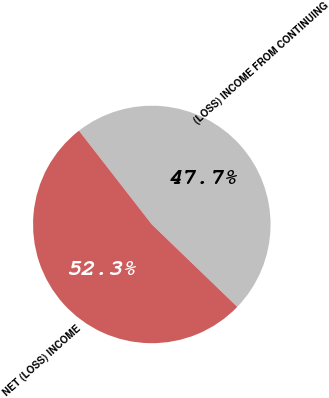Convert chart. <chart><loc_0><loc_0><loc_500><loc_500><pie_chart><fcel>(LOSS) INCOME FROM CONTINUING<fcel>NET (LOSS) INCOME<nl><fcel>47.73%<fcel>52.27%<nl></chart> 